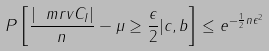Convert formula to latex. <formula><loc_0><loc_0><loc_500><loc_500>P \left [ \frac { | \ m r v { C } _ { I } | } { n } - \mu \geq \frac { \epsilon } { 2 } | c , b \right ] \leq e ^ { - \frac { 1 } { 2 } n \epsilon ^ { 2 } }</formula> 